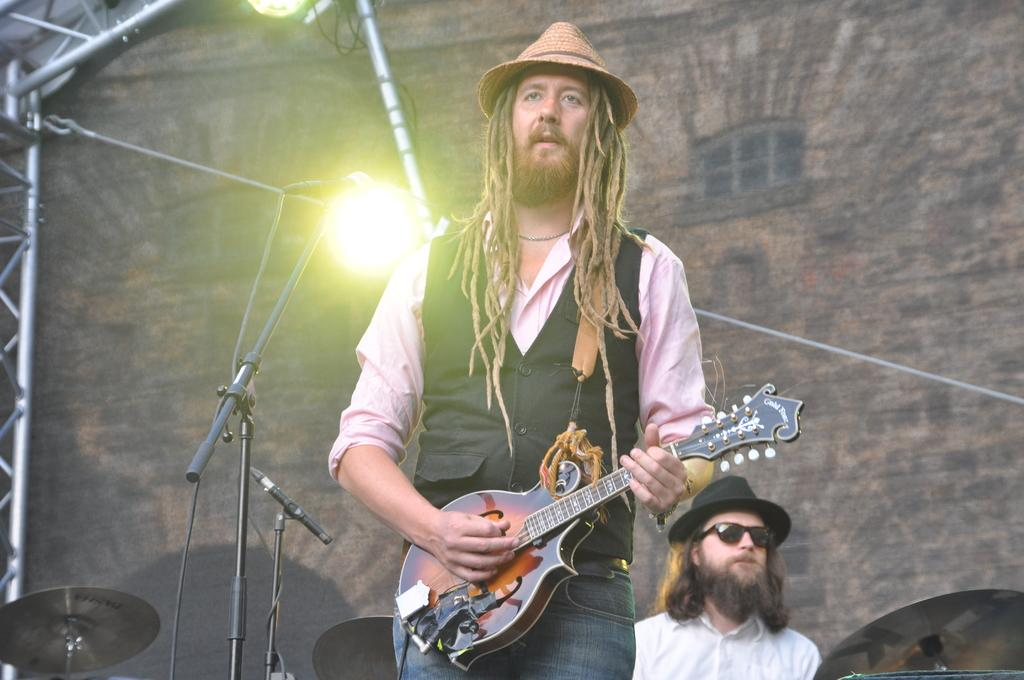What is the man in the black jacket doing in the image? The man in the black jacket is playing a guitar. What is the man in the black jacket standing in front of? The man in the black jacket is in front of a microphone. What can be seen attached to a rod in the image? There is a focusing light attached to a rod in the image. What is the person in the white shirt wearing? The person in the white shirt is wearing goggles and a hat. What type of gold material is used to make the texture of the guitar strings in the image? There is no mention of gold or texture related to the guitar strings in the image. 